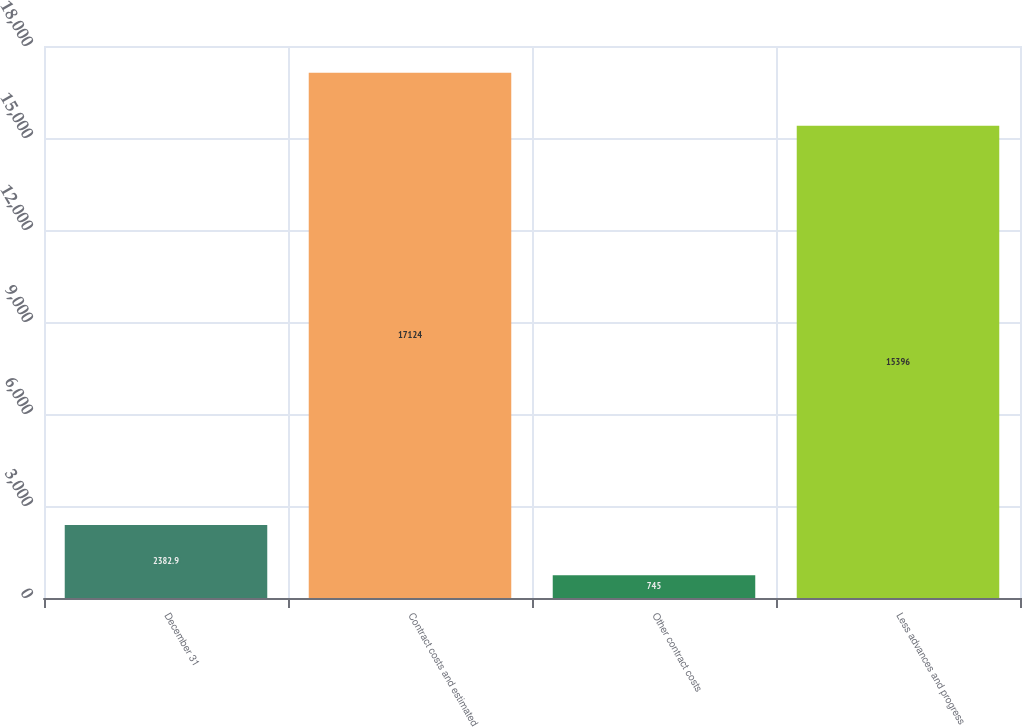Convert chart to OTSL. <chart><loc_0><loc_0><loc_500><loc_500><bar_chart><fcel>December 31<fcel>Contract costs and estimated<fcel>Other contract costs<fcel>Less advances and progress<nl><fcel>2382.9<fcel>17124<fcel>745<fcel>15396<nl></chart> 